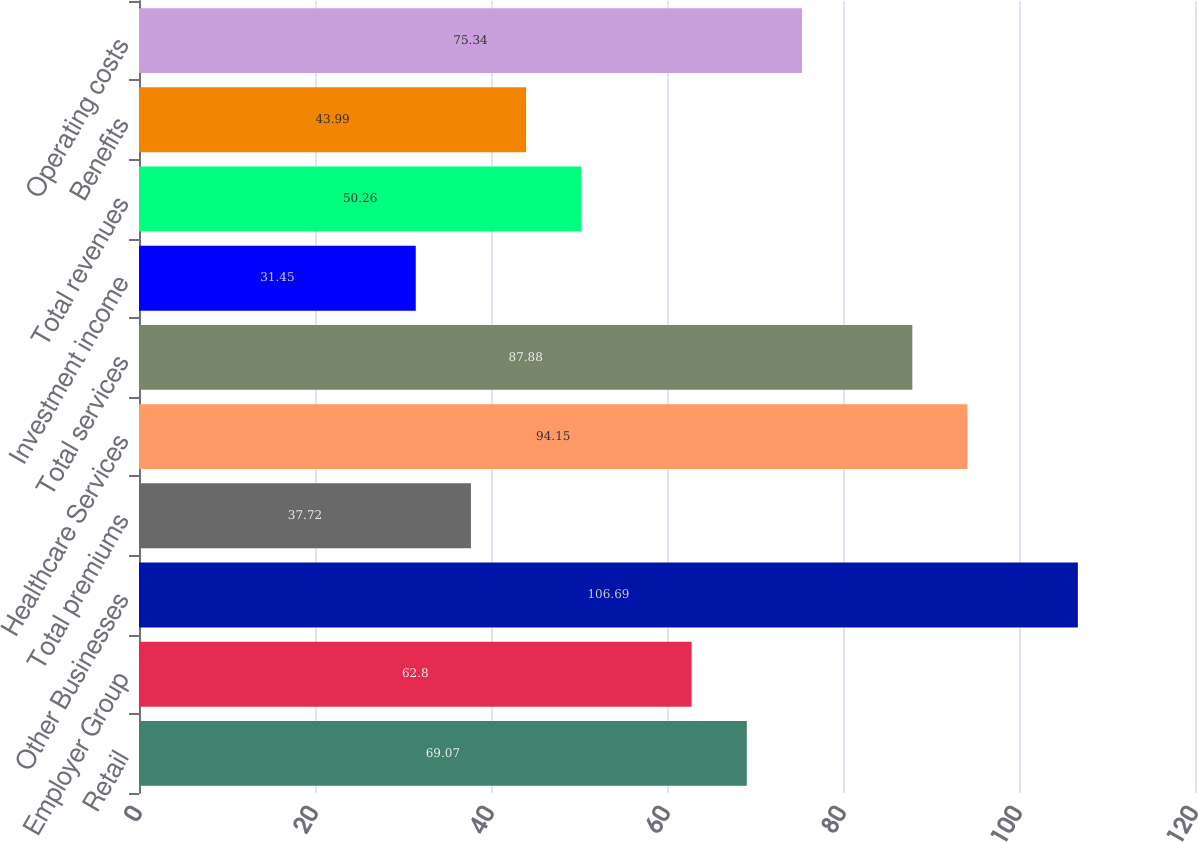<chart> <loc_0><loc_0><loc_500><loc_500><bar_chart><fcel>Retail<fcel>Employer Group<fcel>Other Businesses<fcel>Total premiums<fcel>Healthcare Services<fcel>Total services<fcel>Investment income<fcel>Total revenues<fcel>Benefits<fcel>Operating costs<nl><fcel>69.07<fcel>62.8<fcel>106.69<fcel>37.72<fcel>94.15<fcel>87.88<fcel>31.45<fcel>50.26<fcel>43.99<fcel>75.34<nl></chart> 